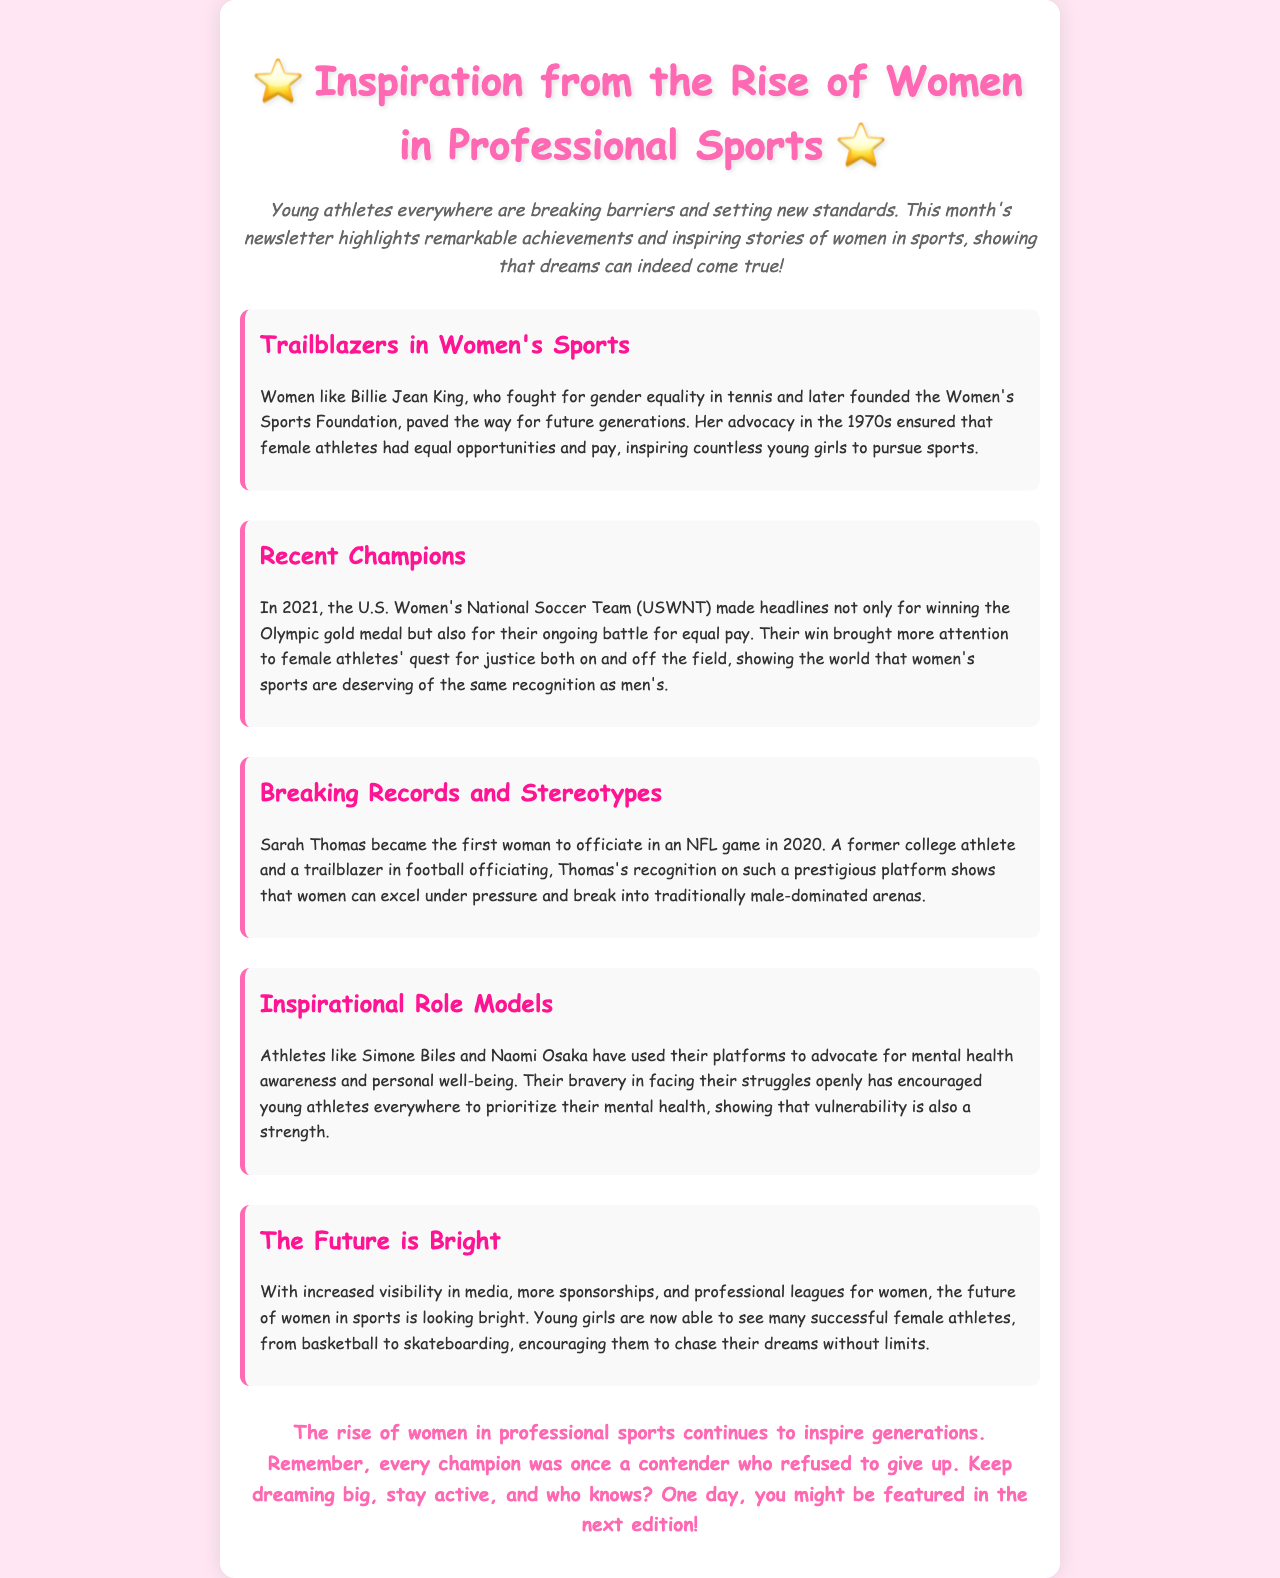What is the title of the newsletter? The title appears at the top of the rendered document, indicating the main theme of the newsletter.
Answer: Inspiration from the Rise of Women in Professional Sports Who is a well-known advocate for gender equality in tennis mentioned in the document? The document describes Billie Jean King and her contributions to women's sports, emphasizing her role in fighting for gender equality.
Answer: Billie Jean King What significant achievement did the U.S. Women's National Soccer Team achieve in 2021? The document highlights their accomplishment, specifically noting a major event recognized by the public.
Answer: Olympic gold medal Who was the first woman to officiate in an NFL game? The document states the name of a trailblazing individual in football officiating, showcasing her historic achievement.
Answer: Sarah Thomas What key issue is referenced alongside the success of the U.S. Women's National Soccer Team? The document discusses an important battle that emphasizes gender parity in sports, indicating ongoing challenges faced by female athletes.
Answer: Equal pay Which two athletes are noted for advocating for mental health awareness? The document mentions these athletes as role models who have bravely addressed mental health issues.
Answer: Simone Biles and Naomi Osaka How does the document describe the future of women in sports? The conclusion reflects on the evolving landscape for female athletes in professional sports, indicating a positive outlook.
Answer: Bright What does the concluding statement suggest about pursuing dreams? The end of the document encourages readers to continue aiming high and staying active, highlighting an important message about perseverance.
Answer: Keep dreaming big 